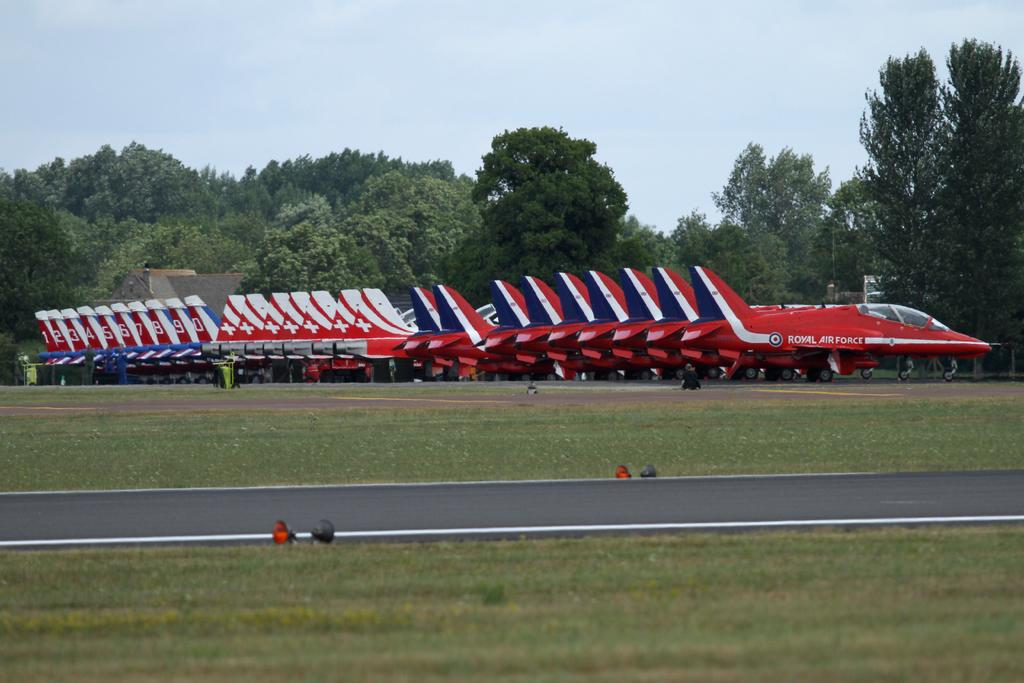What is the main subject of the image? The main subject of the image is aircrafts. What colors are the aircrafts in the image? The aircrafts are in red, blue, and white colors. What can be seen in the background of the image? There are trees and the sky visible in the background of the image. What is the color of the trees in the image? The trees are green. What is the color of the sky in the image? The sky is in a white color. What type of creature is sitting on the oven in the image? There is no oven or creature present in the image. How many cards are visible on the table in the image? There is no table or cards present in the image. 